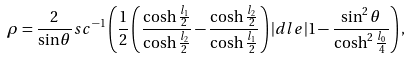<formula> <loc_0><loc_0><loc_500><loc_500>\rho = \frac { 2 } { \sin \theta } s c ^ { - 1 } \left ( \frac { 1 } { 2 } \left ( \frac { \cosh \frac { l _ { 1 } } { 2 } } { \cosh \frac { l _ { 2 } } { 2 } } - \frac { \cosh \frac { l _ { 2 } } { 2 } } { \cosh \frac { l _ { 1 } } { 2 } } \right ) | d l e | 1 - \frac { \sin ^ { 2 } \theta } { \cosh ^ { 2 } \frac { l _ { 0 } } { 4 } } \right ) ,</formula> 